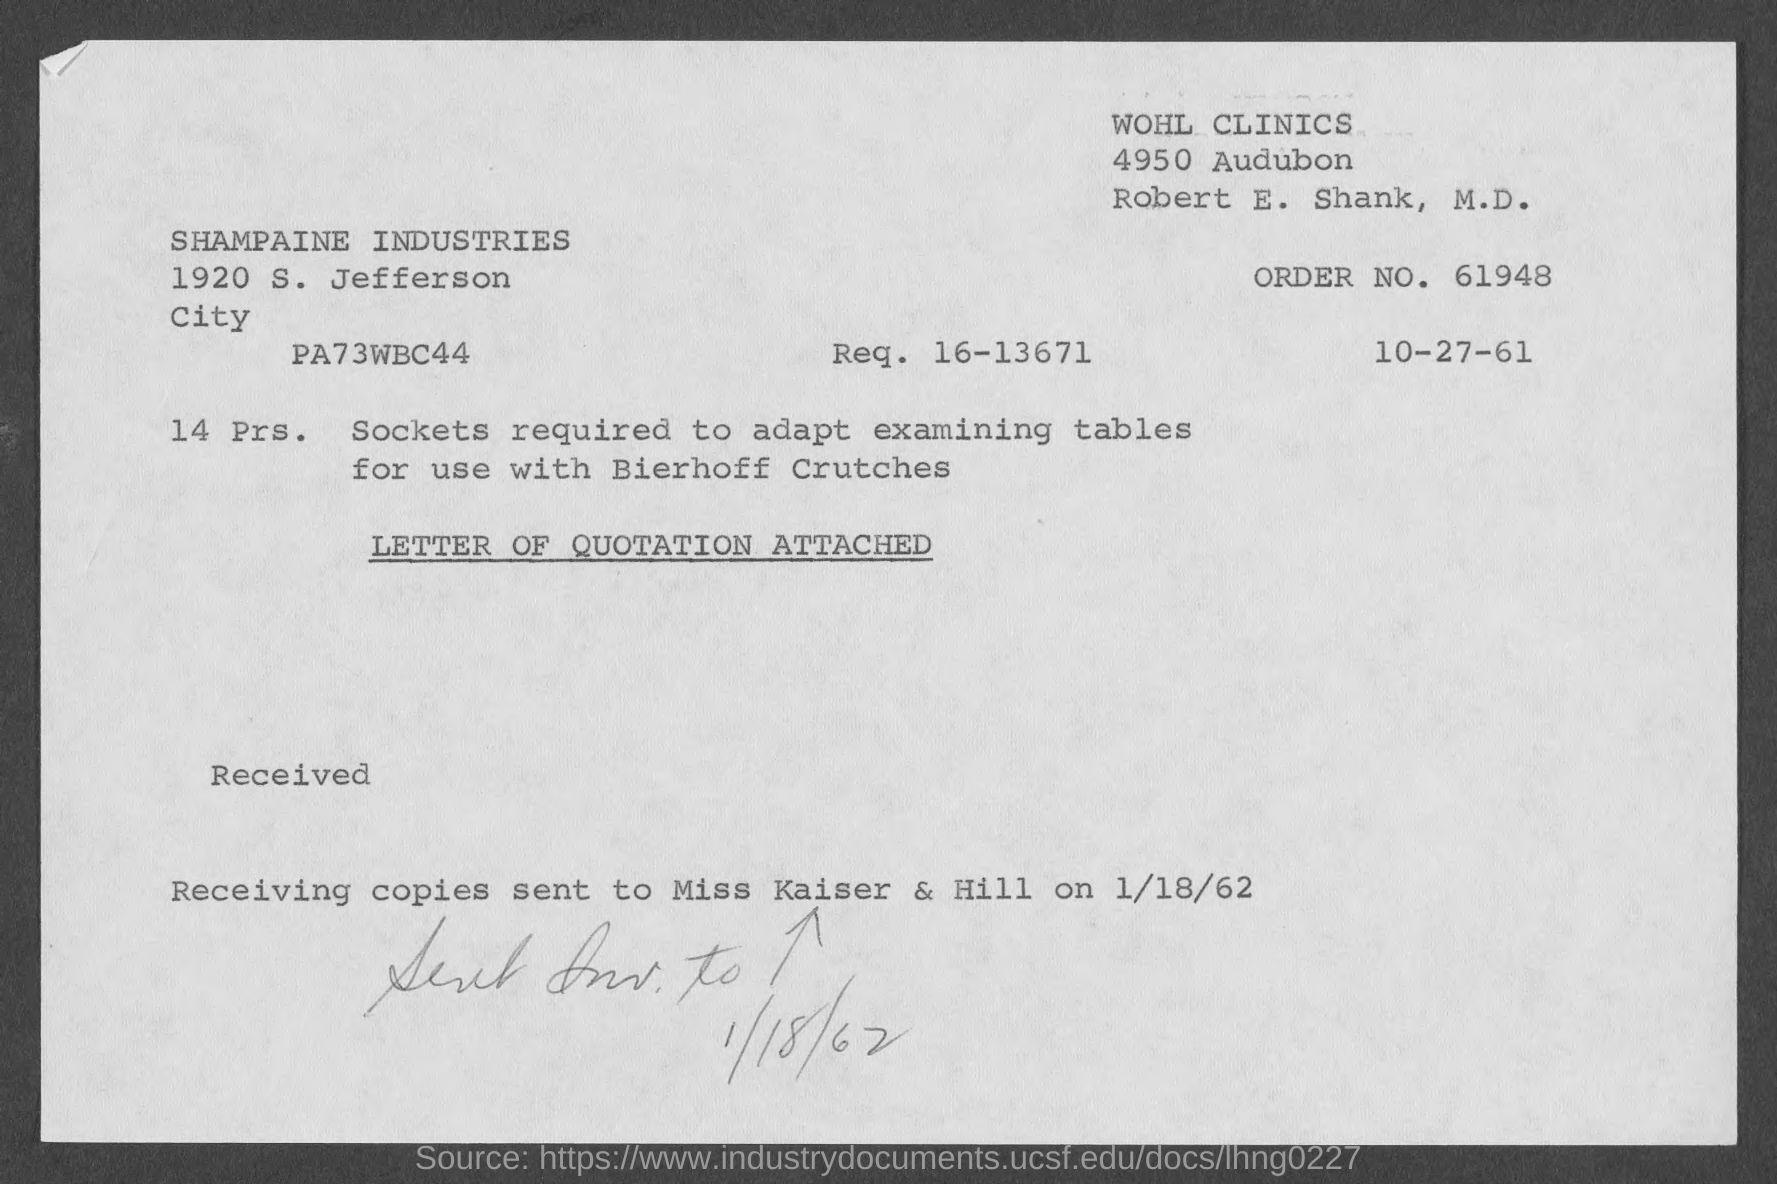What is the Order No?
Give a very brief answer. 61948. 